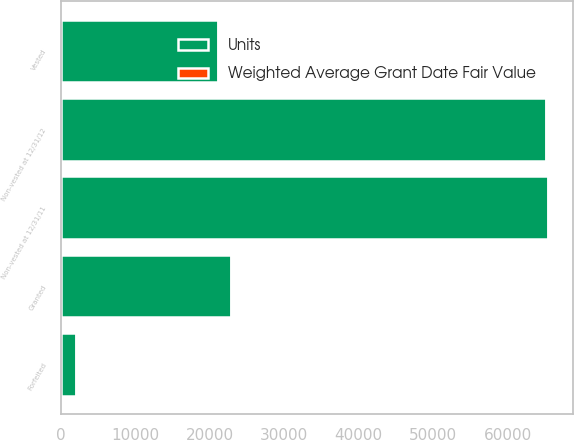Convert chart. <chart><loc_0><loc_0><loc_500><loc_500><stacked_bar_chart><ecel><fcel>Non-vested at 12/31/11<fcel>Granted<fcel>Vested<fcel>Forfeited<fcel>Non-vested at 12/31/12<nl><fcel>Units<fcel>65420<fcel>22860<fcel>21130<fcel>2010<fcel>65140<nl><fcel>Weighted Average Grant Date Fair Value<fcel>45.05<fcel>58.42<fcel>39.61<fcel>50.45<fcel>51.34<nl></chart> 